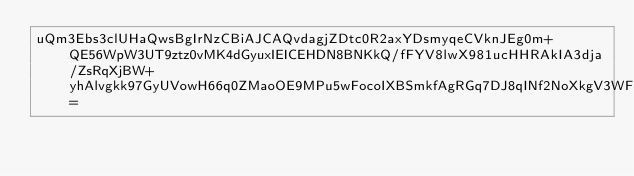<code> <loc_0><loc_0><loc_500><loc_500><_SML_>uQm3Ebs3clUHaQwsBgIrNzCBiAJCAQvdagjZDtc0R2axYDsmyqeCVknJEg0m+QE56WpW3UT9ztz0vMK4dGyuxIEICEHDN8BNKkQ/fFYV8lwX981ucHHRAkIA3dja/ZsRqXjBW+yhAlvgkk97GyUVowH66q0ZMaoOE9MPu5wFocoIXBSmkfAgRGq7DJ8qINf2NoXkgV3WFUQEtH0=</code> 